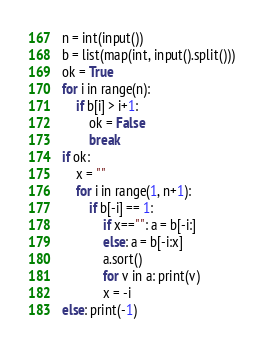<code> <loc_0><loc_0><loc_500><loc_500><_Python_>n = int(input())
b = list(map(int, input().split()))
ok = True
for i in range(n):
    if b[i] > i+1:
        ok = False
        break
if ok:
    x = ""
    for i in range(1, n+1):
        if b[-i] == 1:
            if x=="": a = b[-i:]
            else: a = b[-i:x]
            a.sort()
            for v in a: print(v)
            x = -i
else: print(-1)</code> 